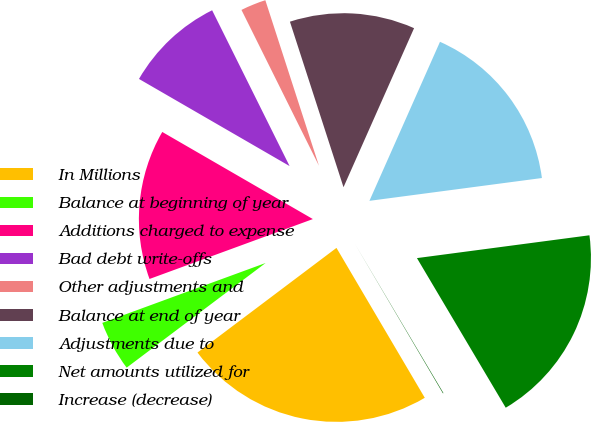Convert chart to OTSL. <chart><loc_0><loc_0><loc_500><loc_500><pie_chart><fcel>In Millions<fcel>Balance at beginning of year<fcel>Additions charged to expense<fcel>Bad debt write-offs<fcel>Other adjustments and<fcel>Balance at end of year<fcel>Adjustments due to<fcel>Net amounts utilized for<fcel>Increase (decrease)<nl><fcel>23.2%<fcel>4.68%<fcel>13.94%<fcel>9.31%<fcel>2.36%<fcel>11.63%<fcel>16.26%<fcel>18.57%<fcel>0.05%<nl></chart> 